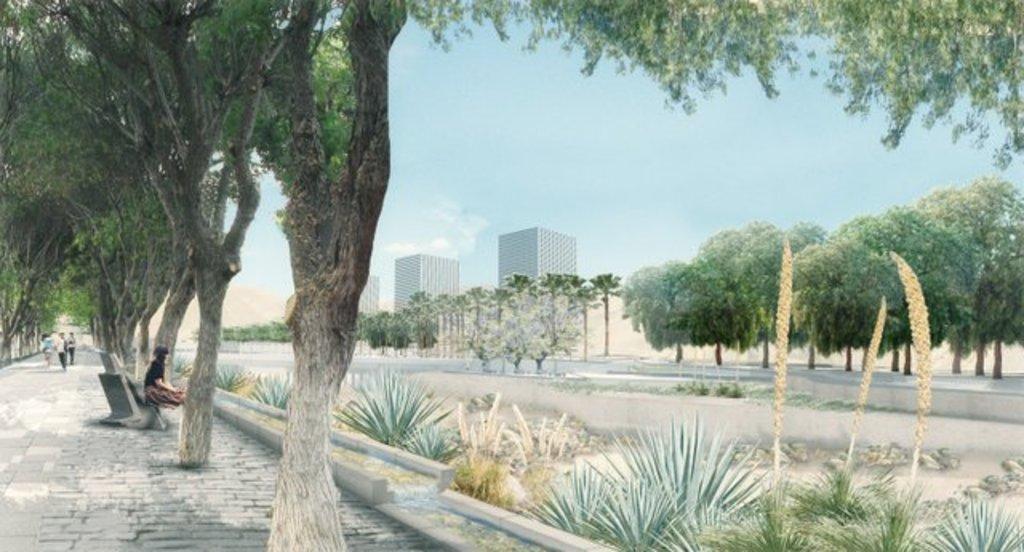How would you summarize this image in a sentence or two? In this image I can see three persons standing and I can see the person sitting on the concrete bench. Background I can see few plants and trees in green color, buildings in white color and the sky is in blue and white color. 